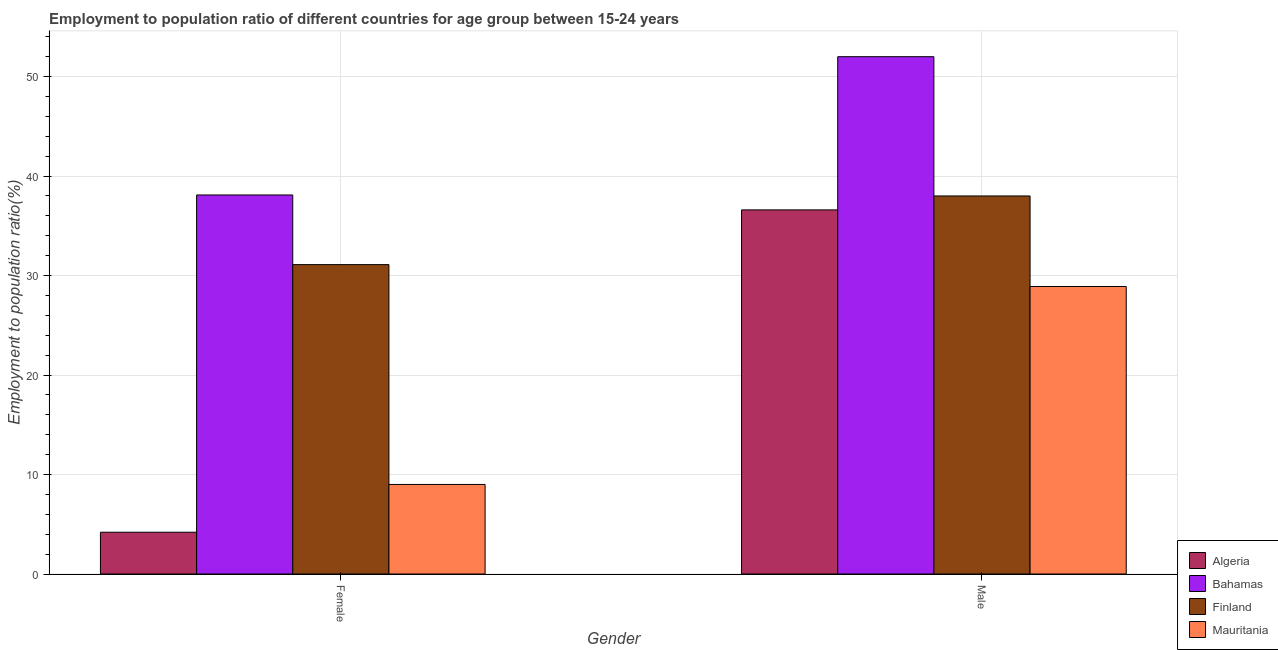How many different coloured bars are there?
Your answer should be compact. 4. Are the number of bars per tick equal to the number of legend labels?
Keep it short and to the point. Yes. Are the number of bars on each tick of the X-axis equal?
Offer a terse response. Yes. What is the label of the 1st group of bars from the left?
Offer a very short reply. Female. What is the employment to population ratio(male) in Mauritania?
Keep it short and to the point. 28.9. Across all countries, what is the maximum employment to population ratio(female)?
Provide a succinct answer. 38.1. Across all countries, what is the minimum employment to population ratio(male)?
Your answer should be compact. 28.9. In which country was the employment to population ratio(female) maximum?
Keep it short and to the point. Bahamas. In which country was the employment to population ratio(male) minimum?
Your answer should be compact. Mauritania. What is the total employment to population ratio(male) in the graph?
Your answer should be compact. 155.5. What is the difference between the employment to population ratio(female) in Finland and that in Bahamas?
Your response must be concise. -7. What is the difference between the employment to population ratio(female) in Finland and the employment to population ratio(male) in Bahamas?
Keep it short and to the point. -20.9. What is the average employment to population ratio(female) per country?
Your answer should be very brief. 20.6. What is the difference between the employment to population ratio(female) and employment to population ratio(male) in Finland?
Keep it short and to the point. -6.9. In how many countries, is the employment to population ratio(male) greater than 2 %?
Make the answer very short. 4. What is the ratio of the employment to population ratio(female) in Mauritania to that in Algeria?
Offer a terse response. 2.14. Is the employment to population ratio(female) in Mauritania less than that in Bahamas?
Provide a short and direct response. Yes. In how many countries, is the employment to population ratio(female) greater than the average employment to population ratio(female) taken over all countries?
Keep it short and to the point. 2. Are all the bars in the graph horizontal?
Make the answer very short. No. What is the difference between two consecutive major ticks on the Y-axis?
Offer a very short reply. 10. Are the values on the major ticks of Y-axis written in scientific E-notation?
Provide a short and direct response. No. How are the legend labels stacked?
Make the answer very short. Vertical. What is the title of the graph?
Keep it short and to the point. Employment to population ratio of different countries for age group between 15-24 years. What is the label or title of the Y-axis?
Keep it short and to the point. Employment to population ratio(%). What is the Employment to population ratio(%) in Algeria in Female?
Provide a succinct answer. 4.2. What is the Employment to population ratio(%) of Bahamas in Female?
Keep it short and to the point. 38.1. What is the Employment to population ratio(%) of Finland in Female?
Offer a very short reply. 31.1. What is the Employment to population ratio(%) in Mauritania in Female?
Your response must be concise. 9. What is the Employment to population ratio(%) in Algeria in Male?
Your response must be concise. 36.6. What is the Employment to population ratio(%) in Finland in Male?
Keep it short and to the point. 38. What is the Employment to population ratio(%) of Mauritania in Male?
Offer a very short reply. 28.9. Across all Gender, what is the maximum Employment to population ratio(%) in Algeria?
Give a very brief answer. 36.6. Across all Gender, what is the maximum Employment to population ratio(%) in Mauritania?
Offer a very short reply. 28.9. Across all Gender, what is the minimum Employment to population ratio(%) in Algeria?
Your answer should be very brief. 4.2. Across all Gender, what is the minimum Employment to population ratio(%) in Bahamas?
Ensure brevity in your answer.  38.1. Across all Gender, what is the minimum Employment to population ratio(%) of Finland?
Give a very brief answer. 31.1. What is the total Employment to population ratio(%) of Algeria in the graph?
Your answer should be very brief. 40.8. What is the total Employment to population ratio(%) in Bahamas in the graph?
Offer a terse response. 90.1. What is the total Employment to population ratio(%) in Finland in the graph?
Ensure brevity in your answer.  69.1. What is the total Employment to population ratio(%) in Mauritania in the graph?
Keep it short and to the point. 37.9. What is the difference between the Employment to population ratio(%) of Algeria in Female and that in Male?
Keep it short and to the point. -32.4. What is the difference between the Employment to population ratio(%) in Bahamas in Female and that in Male?
Your response must be concise. -13.9. What is the difference between the Employment to population ratio(%) of Mauritania in Female and that in Male?
Your answer should be compact. -19.9. What is the difference between the Employment to population ratio(%) in Algeria in Female and the Employment to population ratio(%) in Bahamas in Male?
Provide a succinct answer. -47.8. What is the difference between the Employment to population ratio(%) of Algeria in Female and the Employment to population ratio(%) of Finland in Male?
Provide a short and direct response. -33.8. What is the difference between the Employment to population ratio(%) in Algeria in Female and the Employment to population ratio(%) in Mauritania in Male?
Provide a succinct answer. -24.7. What is the difference between the Employment to population ratio(%) in Finland in Female and the Employment to population ratio(%) in Mauritania in Male?
Keep it short and to the point. 2.2. What is the average Employment to population ratio(%) in Algeria per Gender?
Your response must be concise. 20.4. What is the average Employment to population ratio(%) of Bahamas per Gender?
Provide a short and direct response. 45.05. What is the average Employment to population ratio(%) in Finland per Gender?
Make the answer very short. 34.55. What is the average Employment to population ratio(%) of Mauritania per Gender?
Make the answer very short. 18.95. What is the difference between the Employment to population ratio(%) of Algeria and Employment to population ratio(%) of Bahamas in Female?
Provide a succinct answer. -33.9. What is the difference between the Employment to population ratio(%) of Algeria and Employment to population ratio(%) of Finland in Female?
Your answer should be very brief. -26.9. What is the difference between the Employment to population ratio(%) in Bahamas and Employment to population ratio(%) in Mauritania in Female?
Ensure brevity in your answer.  29.1. What is the difference between the Employment to population ratio(%) in Finland and Employment to population ratio(%) in Mauritania in Female?
Ensure brevity in your answer.  22.1. What is the difference between the Employment to population ratio(%) in Algeria and Employment to population ratio(%) in Bahamas in Male?
Keep it short and to the point. -15.4. What is the difference between the Employment to population ratio(%) of Algeria and Employment to population ratio(%) of Finland in Male?
Give a very brief answer. -1.4. What is the difference between the Employment to population ratio(%) of Bahamas and Employment to population ratio(%) of Mauritania in Male?
Your response must be concise. 23.1. What is the ratio of the Employment to population ratio(%) of Algeria in Female to that in Male?
Ensure brevity in your answer.  0.11. What is the ratio of the Employment to population ratio(%) of Bahamas in Female to that in Male?
Your answer should be very brief. 0.73. What is the ratio of the Employment to population ratio(%) of Finland in Female to that in Male?
Make the answer very short. 0.82. What is the ratio of the Employment to population ratio(%) of Mauritania in Female to that in Male?
Your response must be concise. 0.31. What is the difference between the highest and the second highest Employment to population ratio(%) of Algeria?
Offer a terse response. 32.4. What is the difference between the highest and the second highest Employment to population ratio(%) of Finland?
Keep it short and to the point. 6.9. What is the difference between the highest and the lowest Employment to population ratio(%) in Algeria?
Keep it short and to the point. 32.4. What is the difference between the highest and the lowest Employment to population ratio(%) of Bahamas?
Your answer should be compact. 13.9. 